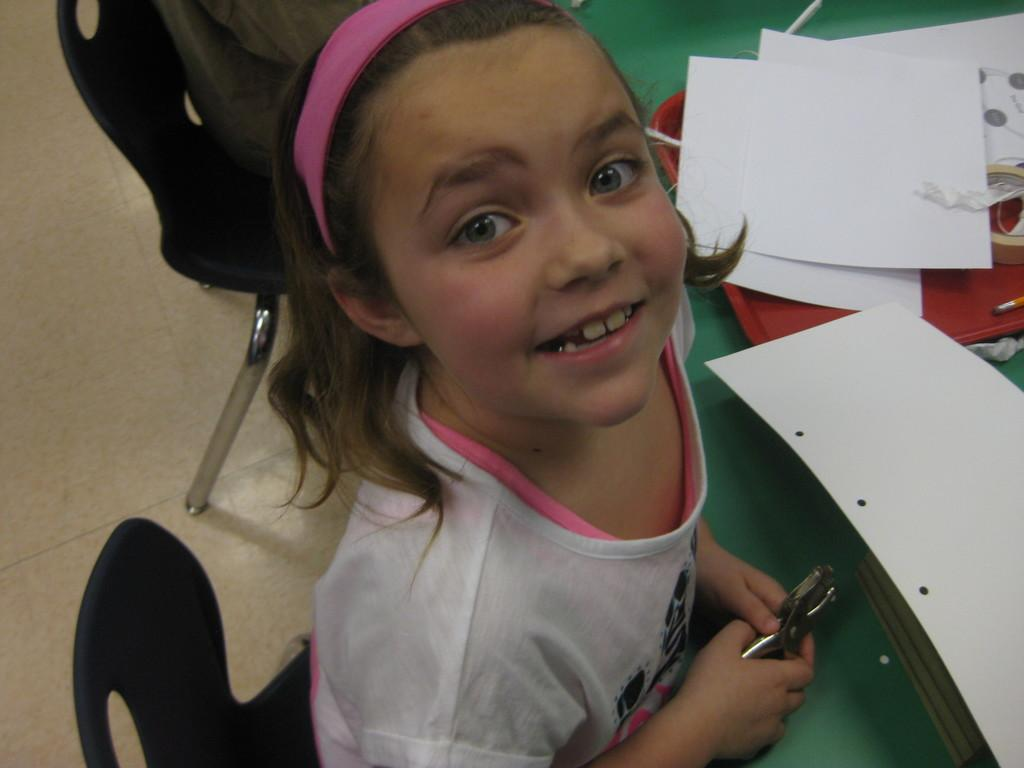What is the girl doing in the image? The girl is sitting on a chair in the image. What is in front of the girl? The girl is in front of a table. What can be seen on the table? There is a tray on the table, along with papers and a brush. Can you describe the setting of the image? The image may have been taken in a hall. What historical event is being discussed by the girl in the image? There is no indication of a historical event being discussed in the image; the girl is simply sitting on a chair in front of a table. 